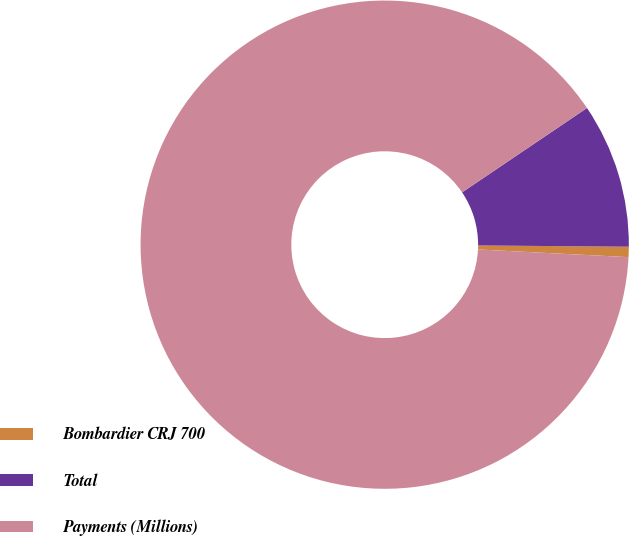Convert chart. <chart><loc_0><loc_0><loc_500><loc_500><pie_chart><fcel>Bombardier CRJ 700<fcel>Total<fcel>Payments (Millions)<nl><fcel>0.68%<fcel>9.59%<fcel>89.73%<nl></chart> 